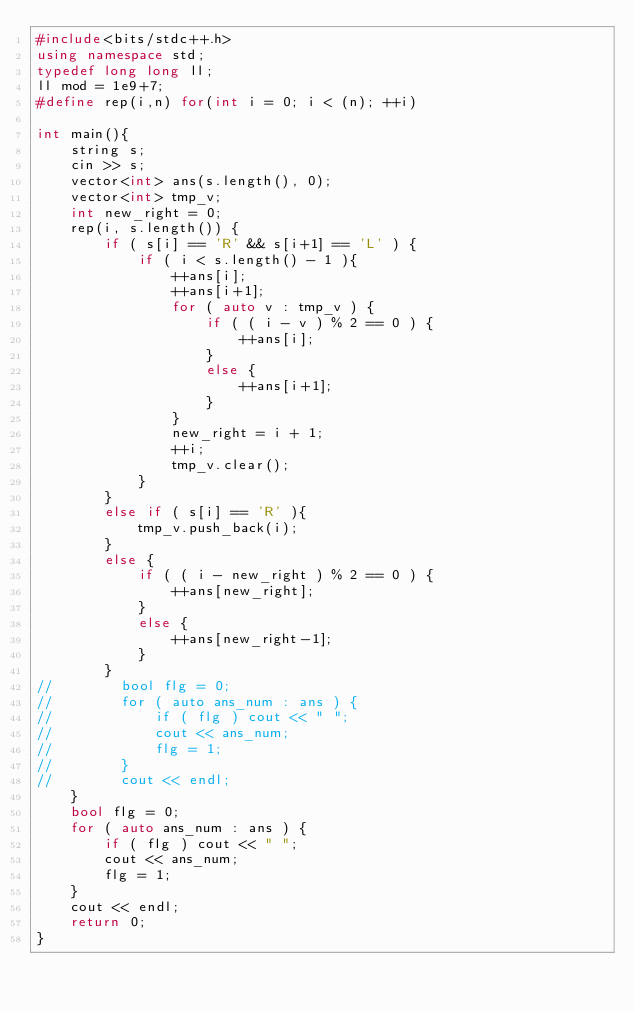Convert code to text. <code><loc_0><loc_0><loc_500><loc_500><_C++_>#include<bits/stdc++.h>
using namespace std;
typedef long long ll;
ll mod = 1e9+7;
#define rep(i,n) for(int i = 0; i < (n); ++i)

int main(){
    string s;
    cin >> s;
    vector<int> ans(s.length(), 0);
    vector<int> tmp_v;
    int new_right = 0;
    rep(i, s.length()) {
        if ( s[i] == 'R' && s[i+1] == 'L' ) {
            if ( i < s.length() - 1 ){
                ++ans[i];
                ++ans[i+1];
                for ( auto v : tmp_v ) {
                    if ( ( i - v ) % 2 == 0 ) {
                        ++ans[i];
                    }
                    else {
                        ++ans[i+1];
                    }
                }
                new_right = i + 1;
                ++i;
                tmp_v.clear();
            }
        }
        else if ( s[i] == 'R' ){
            tmp_v.push_back(i);
        }
        else {
            if ( ( i - new_right ) % 2 == 0 ) {
                ++ans[new_right];
            }
            else {
                ++ans[new_right-1];
            }
        }
//        bool flg = 0;
//        for ( auto ans_num : ans ) {
//            if ( flg ) cout << " ";
//            cout << ans_num;
//            flg = 1;
//        }
//        cout << endl;
    }
    bool flg = 0;
    for ( auto ans_num : ans ) {
        if ( flg ) cout << " ";
        cout << ans_num;
        flg = 1;
    }
    cout << endl;
    return 0;
}
</code> 